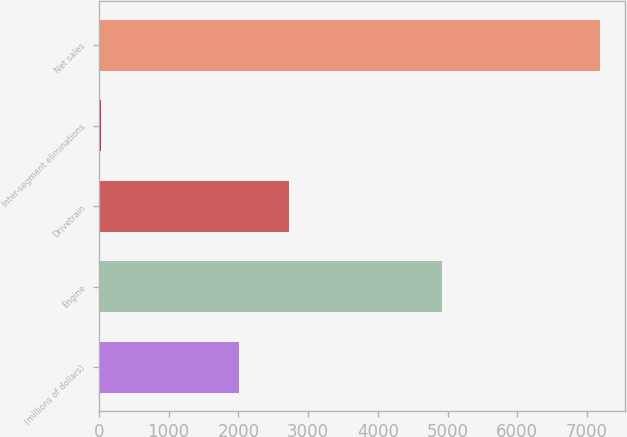Convert chart to OTSL. <chart><loc_0><loc_0><loc_500><loc_500><bar_chart><fcel>(millions of dollars)<fcel>Engine<fcel>Drivetrain<fcel>Inter-segment eliminations<fcel>Net sales<nl><fcel>2012<fcel>4913<fcel>2727.47<fcel>28.5<fcel>7183.2<nl></chart> 